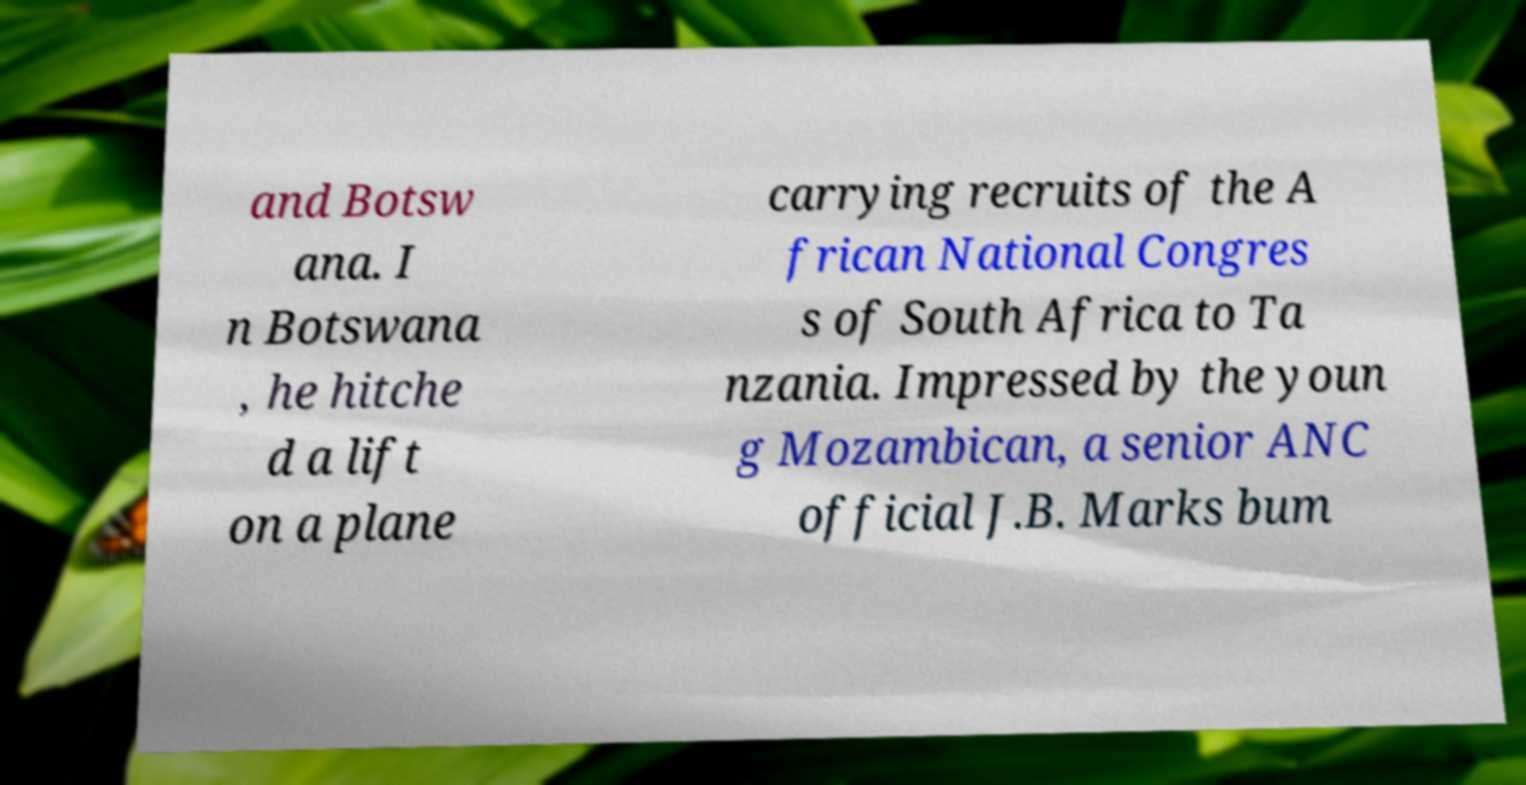Could you assist in decoding the text presented in this image and type it out clearly? and Botsw ana. I n Botswana , he hitche d a lift on a plane carrying recruits of the A frican National Congres s of South Africa to Ta nzania. Impressed by the youn g Mozambican, a senior ANC official J.B. Marks bum 